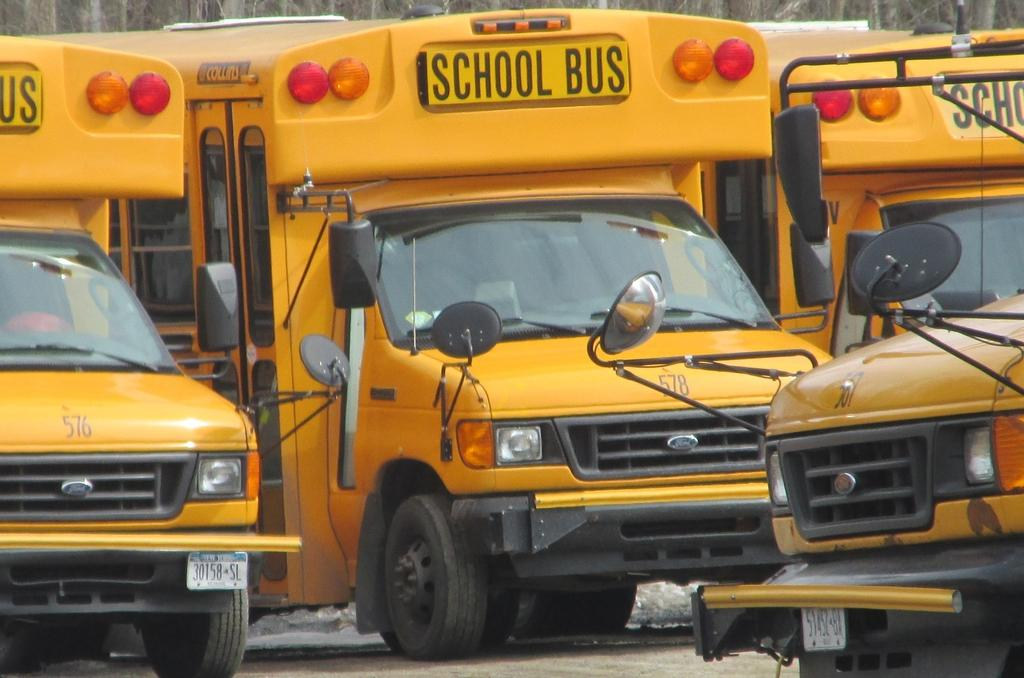What type of vehicles are present in the image? There are buses in the image. What can be seen illuminating the scene in the image? There are lights visible in the image. What type of signage is present in the image? There are boards in the image. What can be seen on the vehicles to identify them? There are number plates in the image. What type of reflective surfaces are present in the image? There are mirrors in the image. Are there any toys visible in the image? There are no toys present in the image. Are there any giants visible in the image? There are no giants present in the image. 